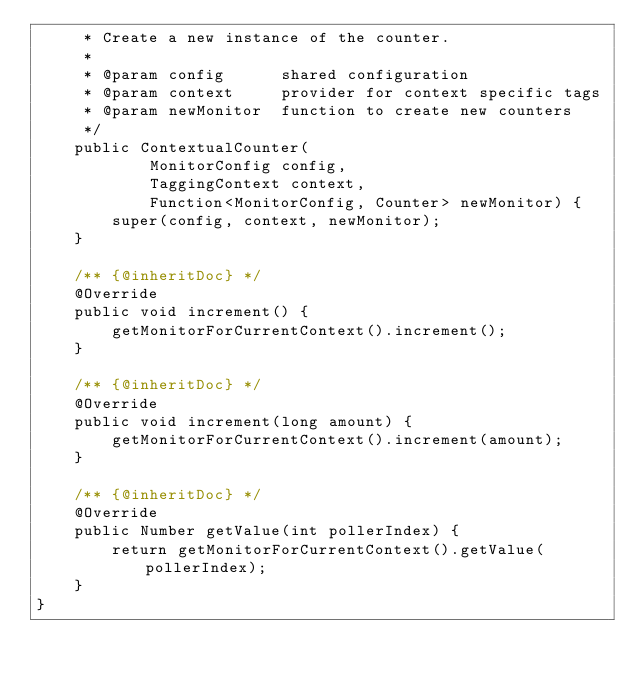<code> <loc_0><loc_0><loc_500><loc_500><_Java_>     * Create a new instance of the counter.
     *
     * @param config      shared configuration
     * @param context     provider for context specific tags
     * @param newMonitor  function to create new counters
     */
    public ContextualCounter(
            MonitorConfig config,
            TaggingContext context,
            Function<MonitorConfig, Counter> newMonitor) {
        super(config, context, newMonitor);
    }

    /** {@inheritDoc} */
    @Override
    public void increment() {
        getMonitorForCurrentContext().increment();
    }

    /** {@inheritDoc} */
    @Override
    public void increment(long amount) {
        getMonitorForCurrentContext().increment(amount);
    }

    /** {@inheritDoc} */
    @Override
    public Number getValue(int pollerIndex) {
        return getMonitorForCurrentContext().getValue(pollerIndex);
    }
}
</code> 